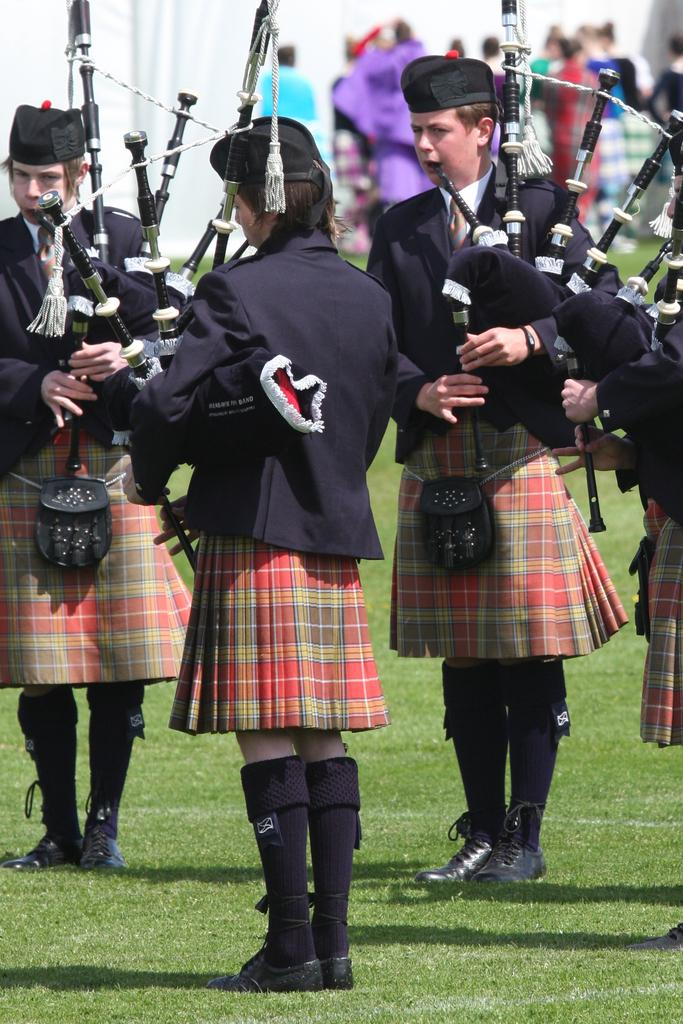Who or what can be seen in the image? There are people in the image. What are the people wearing? The people are wearing different costumes. What are the people holding in their hands? The people are holding something. Can you describe the background of the image? The background of the image is blurred. What type of chain can be seen connecting the elbows of the people in the image? There is no chain connecting the elbows of the people in the image, nor are there any elbows visible. What role does the celery play in the image? There is no celery present in the image. 